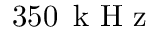<formula> <loc_0><loc_0><loc_500><loc_500>3 5 0 \, k H z</formula> 